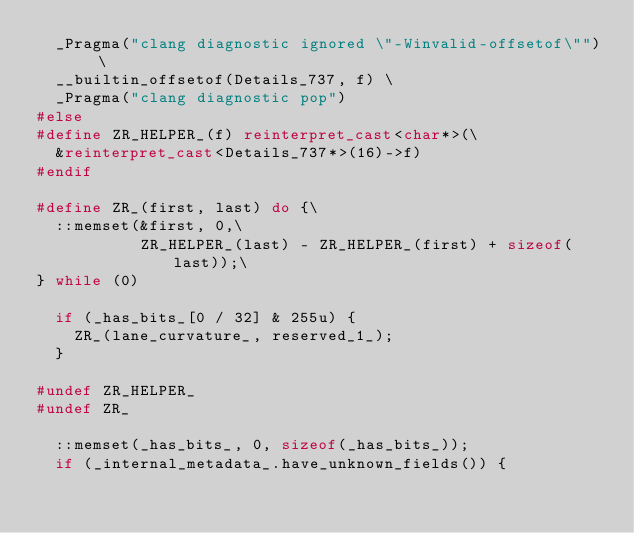<code> <loc_0><loc_0><loc_500><loc_500><_C++_>  _Pragma("clang diagnostic ignored \"-Winvalid-offsetof\"") \
  __builtin_offsetof(Details_737, f) \
  _Pragma("clang diagnostic pop")
#else
#define ZR_HELPER_(f) reinterpret_cast<char*>(\
  &reinterpret_cast<Details_737*>(16)->f)
#endif

#define ZR_(first, last) do {\
  ::memset(&first, 0,\
           ZR_HELPER_(last) - ZR_HELPER_(first) + sizeof(last));\
} while (0)

  if (_has_bits_[0 / 32] & 255u) {
    ZR_(lane_curvature_, reserved_1_);
  }

#undef ZR_HELPER_
#undef ZR_

  ::memset(_has_bits_, 0, sizeof(_has_bits_));
  if (_internal_metadata_.have_unknown_fields()) {</code> 